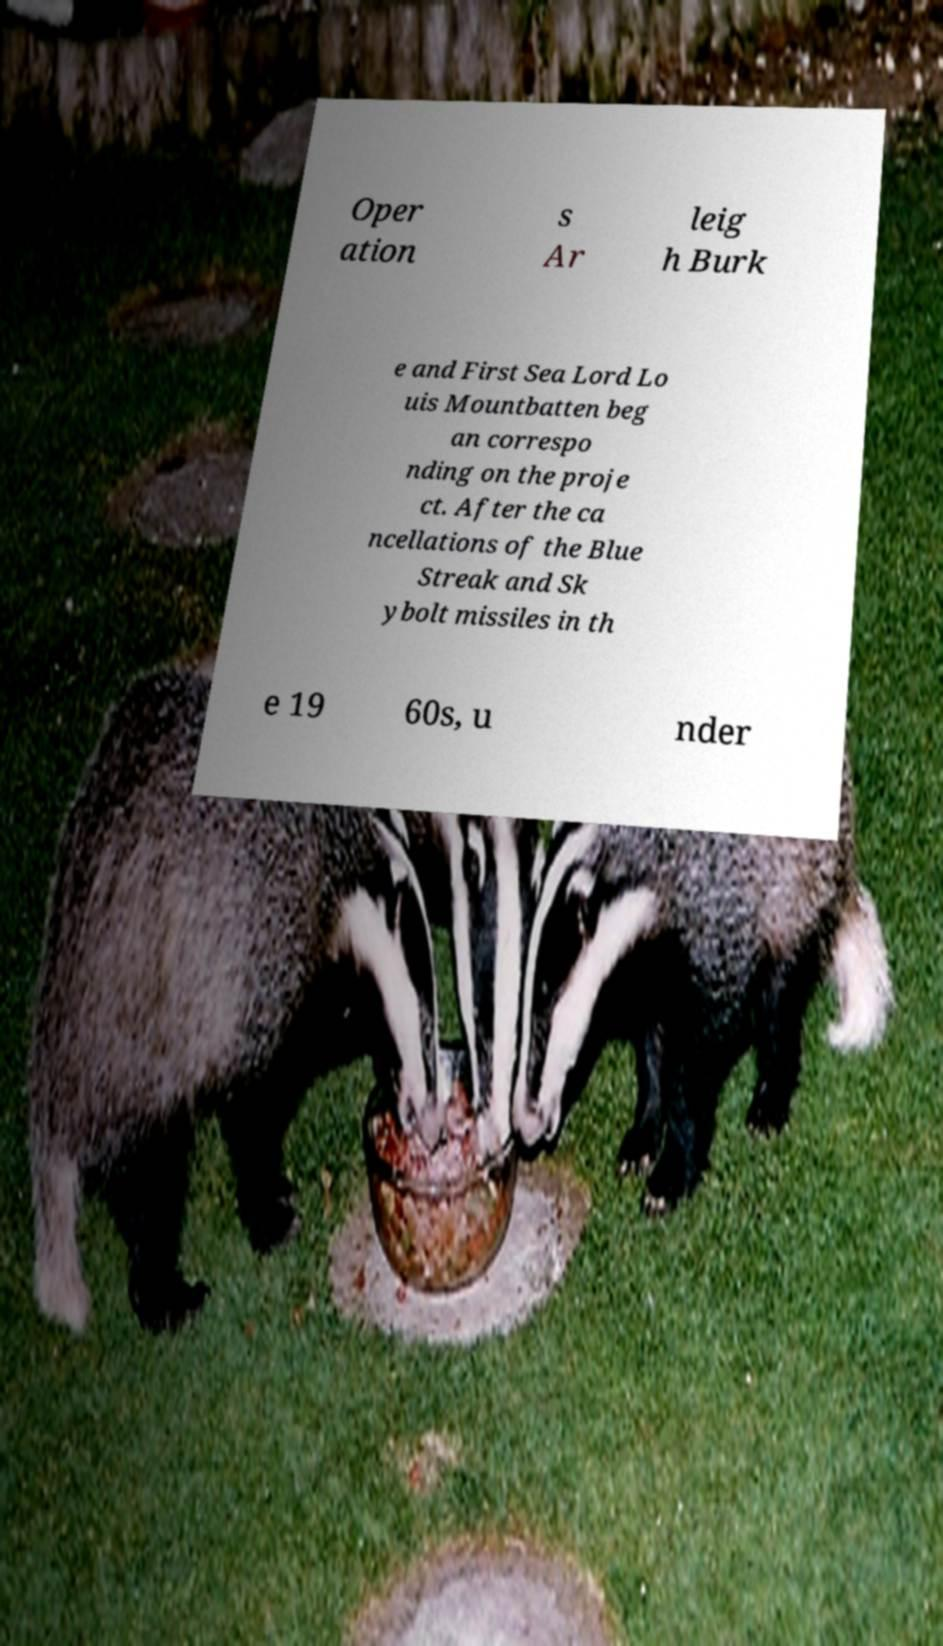Can you read and provide the text displayed in the image?This photo seems to have some interesting text. Can you extract and type it out for me? Oper ation s Ar leig h Burk e and First Sea Lord Lo uis Mountbatten beg an correspo nding on the proje ct. After the ca ncellations of the Blue Streak and Sk ybolt missiles in th e 19 60s, u nder 